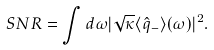<formula> <loc_0><loc_0><loc_500><loc_500>S N R = \int d \omega | \sqrt { \kappa } \langle { \hat { q } } _ { - } \rangle ( \omega ) | ^ { 2 } .</formula> 